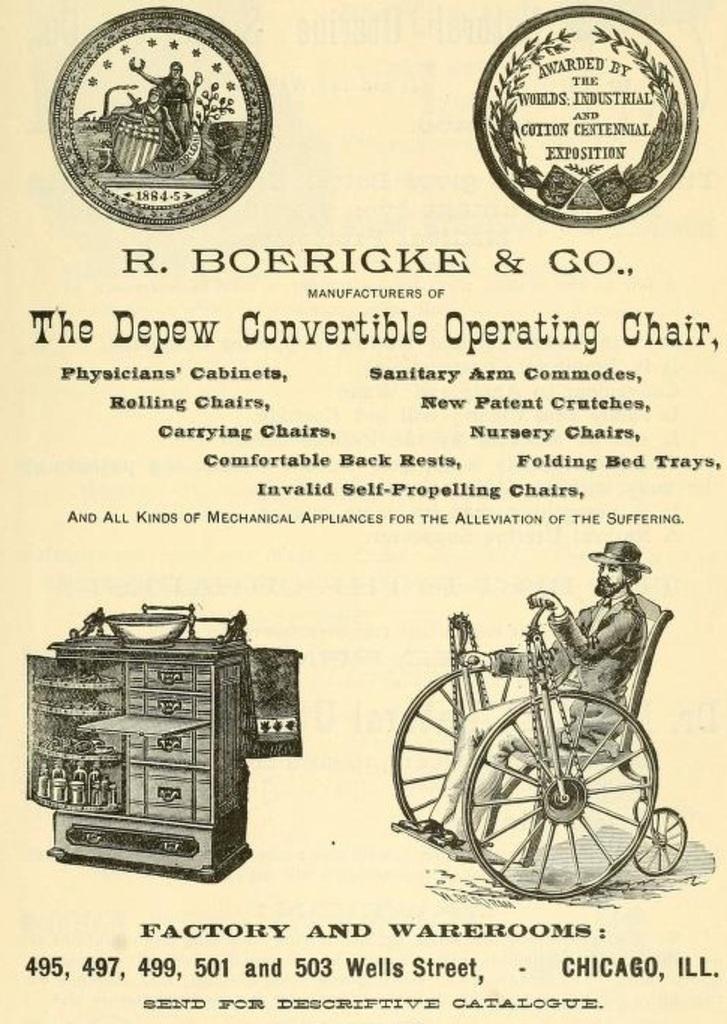In one or two sentences, can you explain what this image depicts? In the image in the center we can see one paper. On paper,we can see one person sitting on wheelchair. And we can see table,drawers,bowl and some signs. And we can see on paper,it is written as "Factory And Warehouse". 